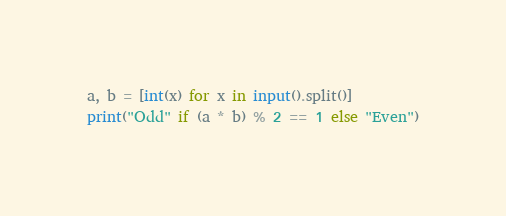Convert code to text. <code><loc_0><loc_0><loc_500><loc_500><_Python_>a, b = [int(x) for x in input().split()]
print("Odd" if (a * b) % 2 == 1 else "Even")</code> 